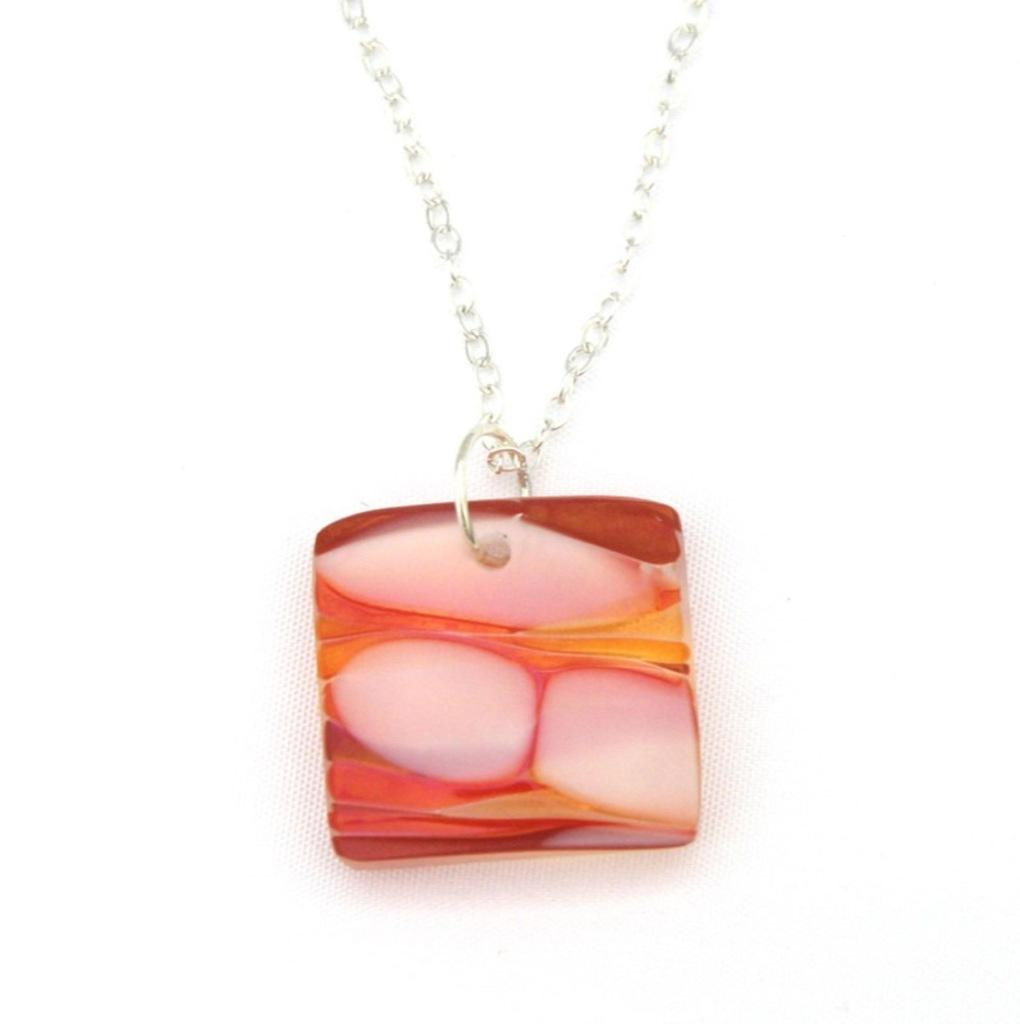What type of jewelry is visible in the image? There is a silver-colored chain and a red and white color locket in the image. What is the color of the locket? The locket is red and white in color. What can be seen in the background of the image? The background of the image is completely white. What level of education does the locket have in the image? The locket is an inanimate object and does not have a level of education. 